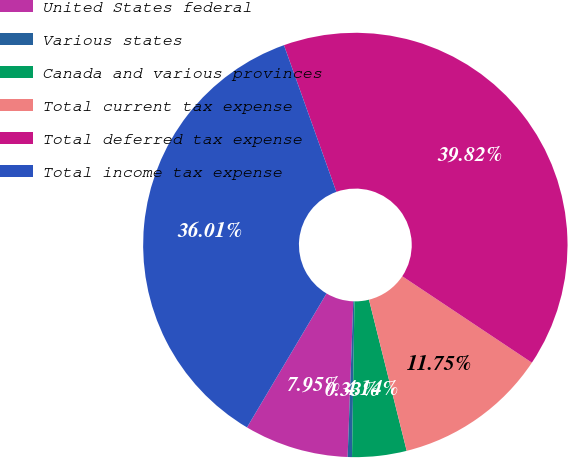Convert chart. <chart><loc_0><loc_0><loc_500><loc_500><pie_chart><fcel>United States federal<fcel>Various states<fcel>Canada and various provinces<fcel>Total current tax expense<fcel>Total deferred tax expense<fcel>Total income tax expense<nl><fcel>7.95%<fcel>0.33%<fcel>4.14%<fcel>11.75%<fcel>39.82%<fcel>36.01%<nl></chart> 